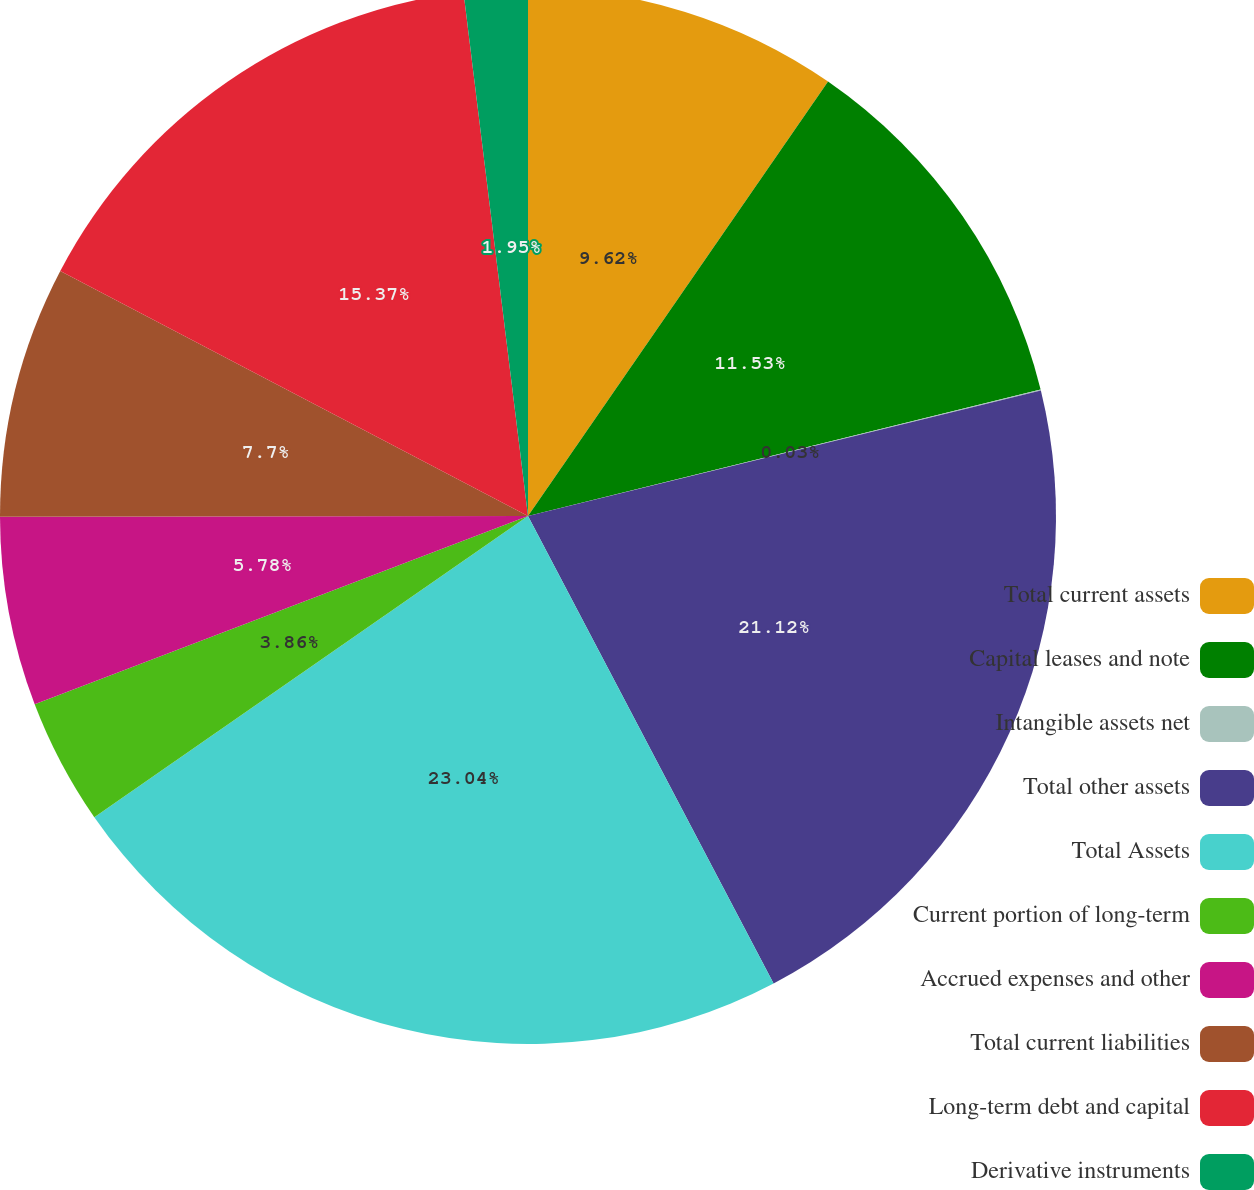Convert chart. <chart><loc_0><loc_0><loc_500><loc_500><pie_chart><fcel>Total current assets<fcel>Capital leases and note<fcel>Intangible assets net<fcel>Total other assets<fcel>Total Assets<fcel>Current portion of long-term<fcel>Accrued expenses and other<fcel>Total current liabilities<fcel>Long-term debt and capital<fcel>Derivative instruments<nl><fcel>9.62%<fcel>11.53%<fcel>0.03%<fcel>21.12%<fcel>23.04%<fcel>3.86%<fcel>5.78%<fcel>7.7%<fcel>15.37%<fcel>1.95%<nl></chart> 